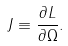<formula> <loc_0><loc_0><loc_500><loc_500>J \equiv \frac { \partial L } { \partial \Omega } .</formula> 